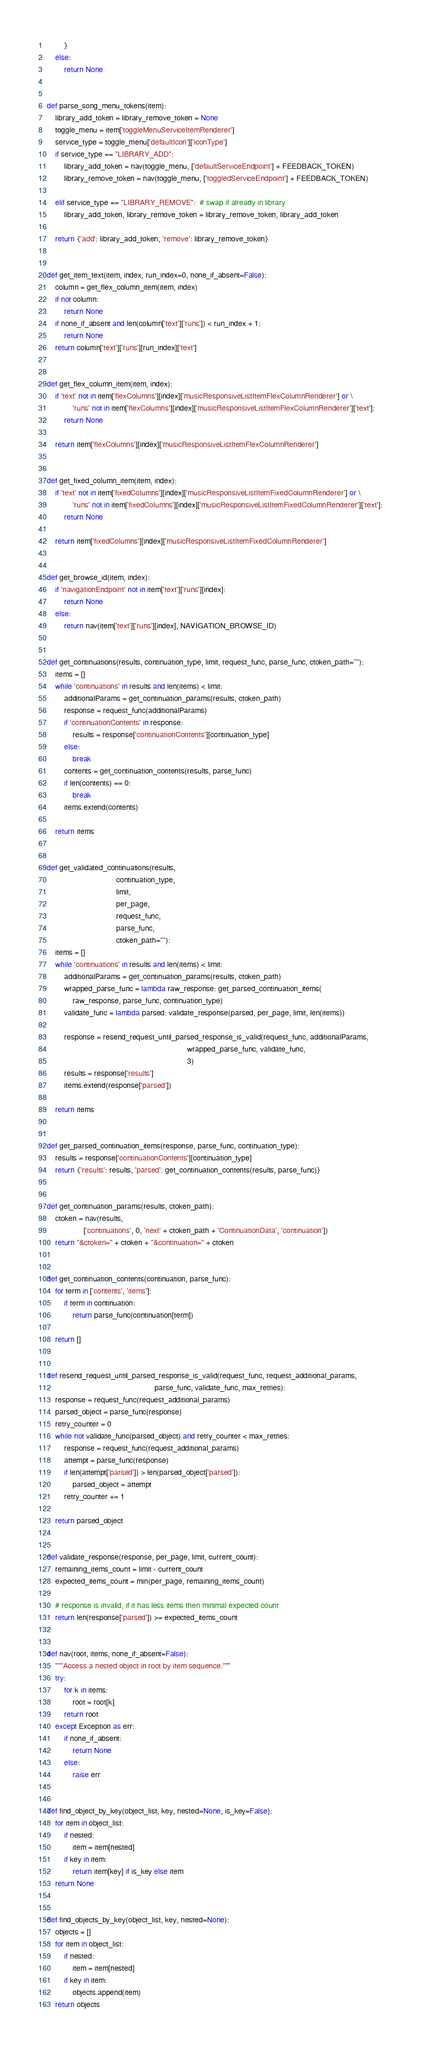Convert code to text. <code><loc_0><loc_0><loc_500><loc_500><_Python_>        }
    else:
        return None


def parse_song_menu_tokens(item):
    library_add_token = library_remove_token = None
    toggle_menu = item['toggleMenuServiceItemRenderer']
    service_type = toggle_menu['defaultIcon']['iconType']
    if service_type == "LIBRARY_ADD":
        library_add_token = nav(toggle_menu, ['defaultServiceEndpoint'] + FEEDBACK_TOKEN)
        library_remove_token = nav(toggle_menu, ['toggledServiceEndpoint'] + FEEDBACK_TOKEN)

    elif service_type == "LIBRARY_REMOVE":  # swap if already in library
        library_add_token, library_remove_token = library_remove_token, library_add_token

    return {'add': library_add_token, 'remove': library_remove_token}


def get_item_text(item, index, run_index=0, none_if_absent=False):
    column = get_flex_column_item(item, index)
    if not column:
        return None
    if none_if_absent and len(column['text']['runs']) < run_index + 1:
        return None
    return column['text']['runs'][run_index]['text']


def get_flex_column_item(item, index):
    if 'text' not in item['flexColumns'][index]['musicResponsiveListItemFlexColumnRenderer'] or \
            'runs' not in item['flexColumns'][index]['musicResponsiveListItemFlexColumnRenderer']['text']:
        return None

    return item['flexColumns'][index]['musicResponsiveListItemFlexColumnRenderer']


def get_fixed_column_item(item, index):
    if 'text' not in item['fixedColumns'][index]['musicResponsiveListItemFixedColumnRenderer'] or \
            'runs' not in item['fixedColumns'][index]['musicResponsiveListItemFixedColumnRenderer']['text']:
        return None

    return item['fixedColumns'][index]['musicResponsiveListItemFixedColumnRenderer']


def get_browse_id(item, index):
    if 'navigationEndpoint' not in item['text']['runs'][index]:
        return None
    else:
        return nav(item['text']['runs'][index], NAVIGATION_BROWSE_ID)


def get_continuations(results, continuation_type, limit, request_func, parse_func, ctoken_path=""):
    items = []
    while 'continuations' in results and len(items) < limit:
        additionalParams = get_continuation_params(results, ctoken_path)
        response = request_func(additionalParams)
        if 'continuationContents' in response:
            results = response['continuationContents'][continuation_type]
        else:
            break
        contents = get_continuation_contents(results, parse_func)
        if len(contents) == 0:
            break
        items.extend(contents)

    return items


def get_validated_continuations(results,
                                continuation_type,
                                limit,
                                per_page,
                                request_func,
                                parse_func,
                                ctoken_path=""):
    items = []
    while 'continuations' in results and len(items) < limit:
        additionalParams = get_continuation_params(results, ctoken_path)
        wrapped_parse_func = lambda raw_response: get_parsed_continuation_items(
            raw_response, parse_func, continuation_type)
        validate_func = lambda parsed: validate_response(parsed, per_page, limit, len(items))

        response = resend_request_until_parsed_response_is_valid(request_func, additionalParams,
                                                                 wrapped_parse_func, validate_func,
                                                                 3)
        results = response['results']
        items.extend(response['parsed'])

    return items


def get_parsed_continuation_items(response, parse_func, continuation_type):
    results = response['continuationContents'][continuation_type]
    return {'results': results, 'parsed': get_continuation_contents(results, parse_func)}


def get_continuation_params(results, ctoken_path):
    ctoken = nav(results,
                 ['continuations', 0, 'next' + ctoken_path + 'ContinuationData', 'continuation'])
    return "&ctoken=" + ctoken + "&continuation=" + ctoken


def get_continuation_contents(continuation, parse_func):
    for term in ['contents', 'items']:
        if term in continuation:
            return parse_func(continuation[term])

    return []


def resend_request_until_parsed_response_is_valid(request_func, request_additional_params,
                                                  parse_func, validate_func, max_retries):
    response = request_func(request_additional_params)
    parsed_object = parse_func(response)
    retry_counter = 0
    while not validate_func(parsed_object) and retry_counter < max_retries:
        response = request_func(request_additional_params)
        attempt = parse_func(response)
        if len(attempt['parsed']) > len(parsed_object['parsed']):
            parsed_object = attempt
        retry_counter += 1

    return parsed_object


def validate_response(response, per_page, limit, current_count):
    remaining_items_count = limit - current_count
    expected_items_count = min(per_page, remaining_items_count)

    # response is invalid, if it has less items then minimal expected count
    return len(response['parsed']) >= expected_items_count


def nav(root, items, none_if_absent=False):
    """Access a nested object in root by item sequence."""
    try:
        for k in items:
            root = root[k]
        return root
    except Exception as err:
        if none_if_absent:
            return None
        else:
            raise err


def find_object_by_key(object_list, key, nested=None, is_key=False):
    for item in object_list:
        if nested:
            item = item[nested]
        if key in item:
            return item[key] if is_key else item
    return None


def find_objects_by_key(object_list, key, nested=None):
    objects = []
    for item in object_list:
        if nested:
            item = item[nested]
        if key in item:
            objects.append(item)
    return objects
</code> 